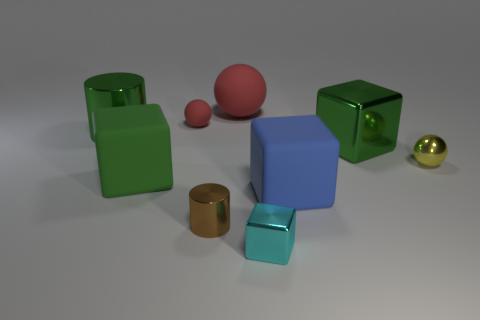There is a brown thing that is the same size as the yellow sphere; what shape is it?
Offer a very short reply. Cylinder. Do the rubber ball that is to the right of the brown cylinder and the yellow sphere have the same size?
Your answer should be compact. No. There is a brown cylinder that is the same size as the cyan cube; what is it made of?
Ensure brevity in your answer.  Metal. Is there a yellow sphere behind the green metal object that is on the left side of the tiny matte ball on the left side of the cyan metallic block?
Provide a short and direct response. No. Is there anything else that has the same shape as the yellow object?
Keep it short and to the point. Yes. There is a big rubber cube that is behind the blue rubber thing; does it have the same color as the cylinder that is behind the tiny metal sphere?
Ensure brevity in your answer.  Yes. Are any brown matte things visible?
Your answer should be compact. No. There is a small object that is the same color as the big matte ball; what is its material?
Provide a short and direct response. Rubber. There is a rubber cube that is right of the large matte thing that is behind the green thing that is to the right of the cyan block; what size is it?
Ensure brevity in your answer.  Large. There is a tiny yellow metallic thing; is its shape the same as the big metal object that is behind the big metallic cube?
Provide a succinct answer. No. 